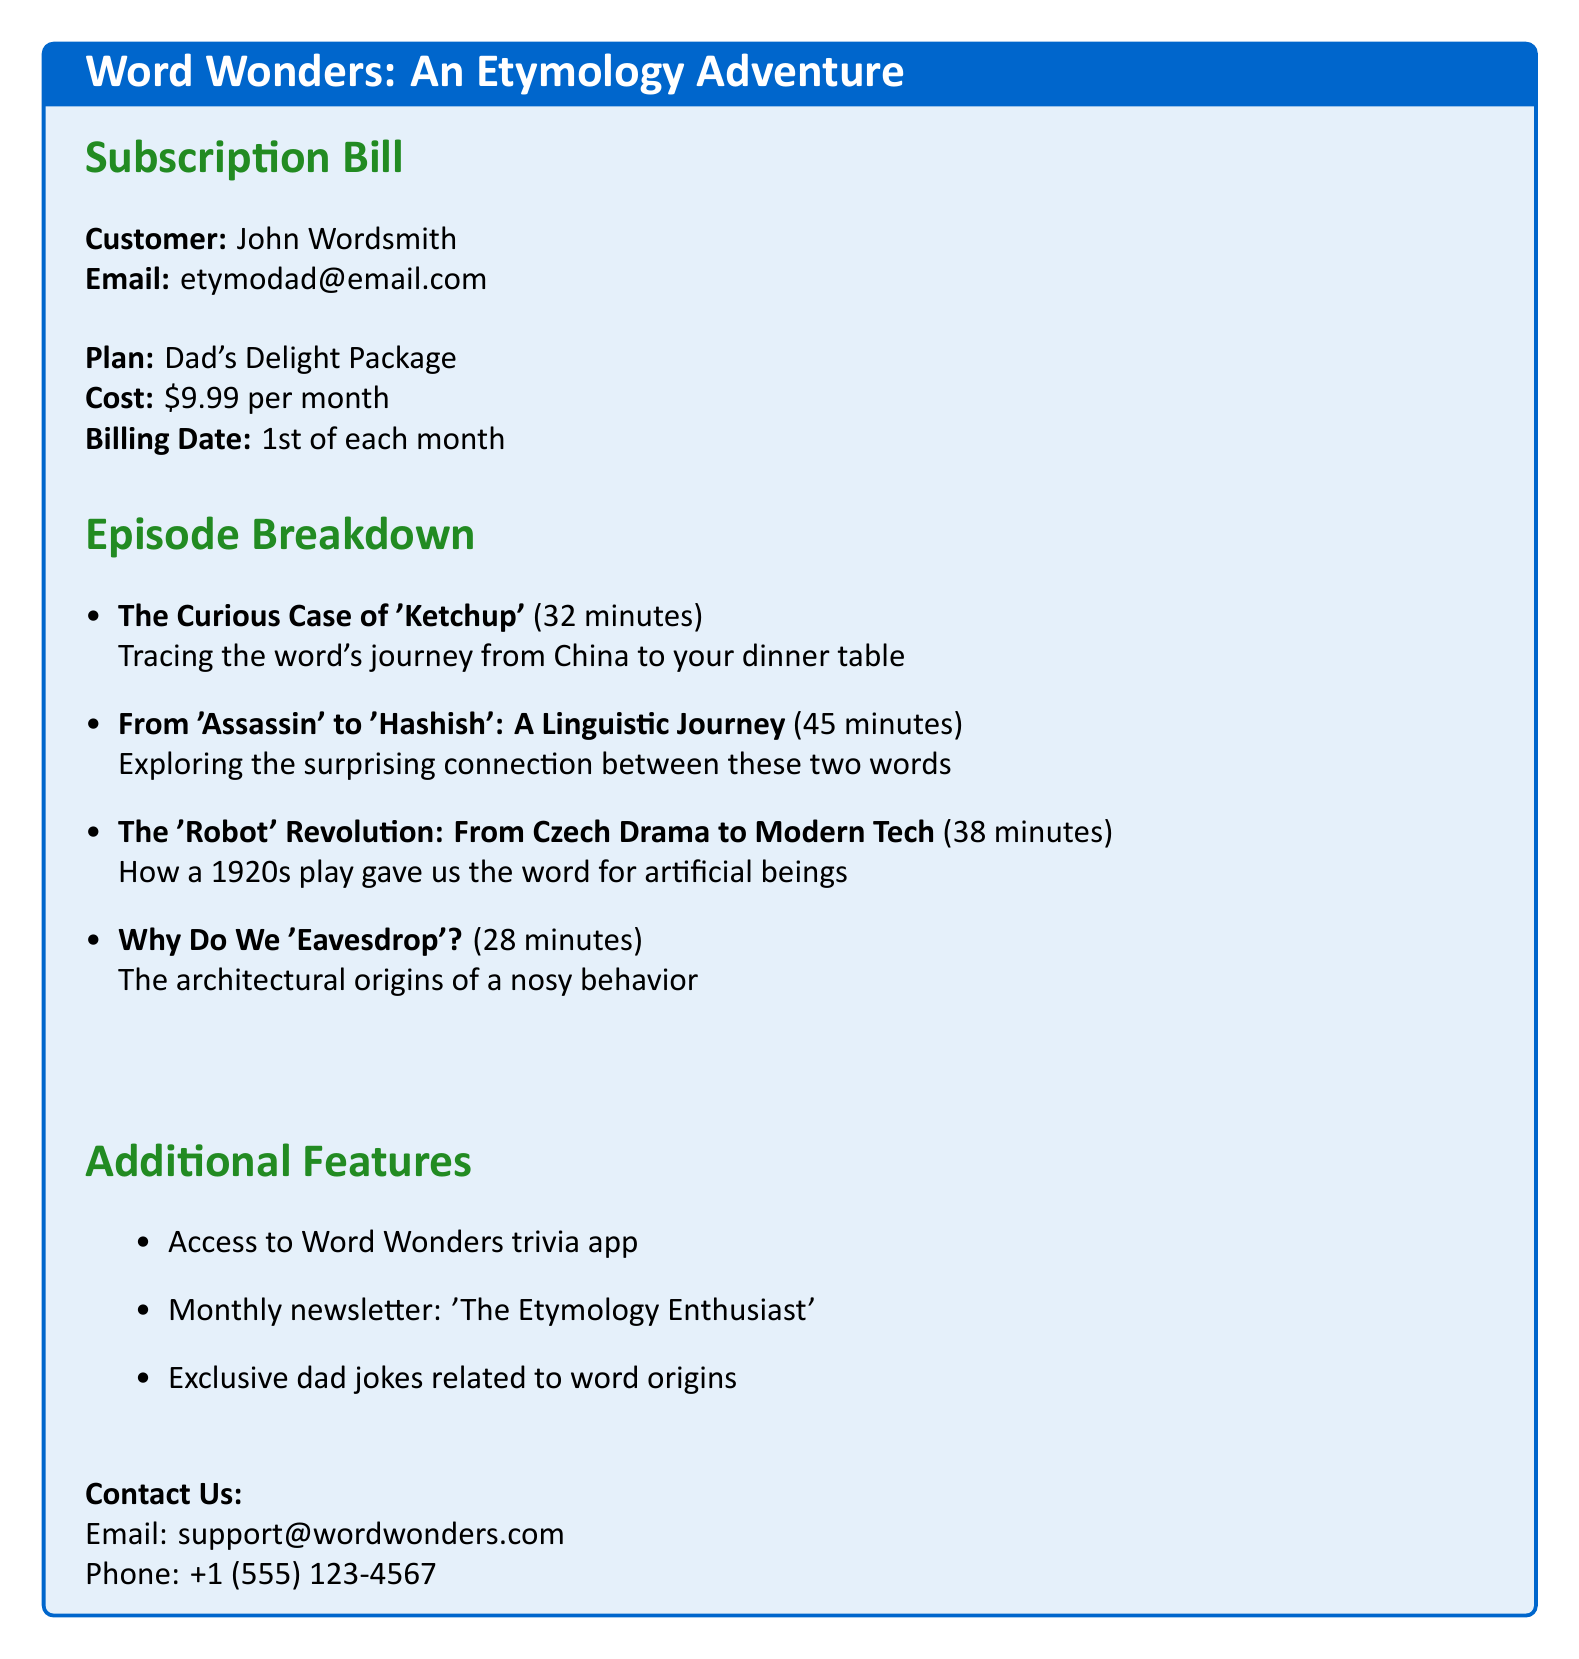What is the customer's name? The document states the customer's name at the beginning, which is John Wordsmith.
Answer: John Wordsmith What is the email address provided? The email address is mentioned directly after the customer's name.
Answer: etymodad@email.com What is the monthly subscription cost? The document specifies the cost of the subscription plan.
Answer: $9.99 When is the billing date each month? The billing date is explicitly stated in the document.
Answer: 1st of each month How long is the episode titled "The Curious Case of 'Ketchup'"? The document lists the duration next to the episode title.
Answer: 32 minutes What is the total duration of all episodes listed? The total duration can be calculated by adding the individual episode durations: 32 + 45 + 38 + 28 = 143 minutes.
Answer: 143 minutes What additional feature mentions a newsletter? The additional features section indicates the presence of a newsletter.
Answer: Monthly newsletter: 'The Etymology Enthusiast' Which episode connects 'Assassin' and 'Hashish'? The title of the respective episode is provided in the breakdown.
Answer: From 'Assassin' to 'Hashish': A Linguistic Journey What is the title of the podcast? The title is prominently displayed at the top of the document.
Answer: Word Wonders: An Etymology Adventure 